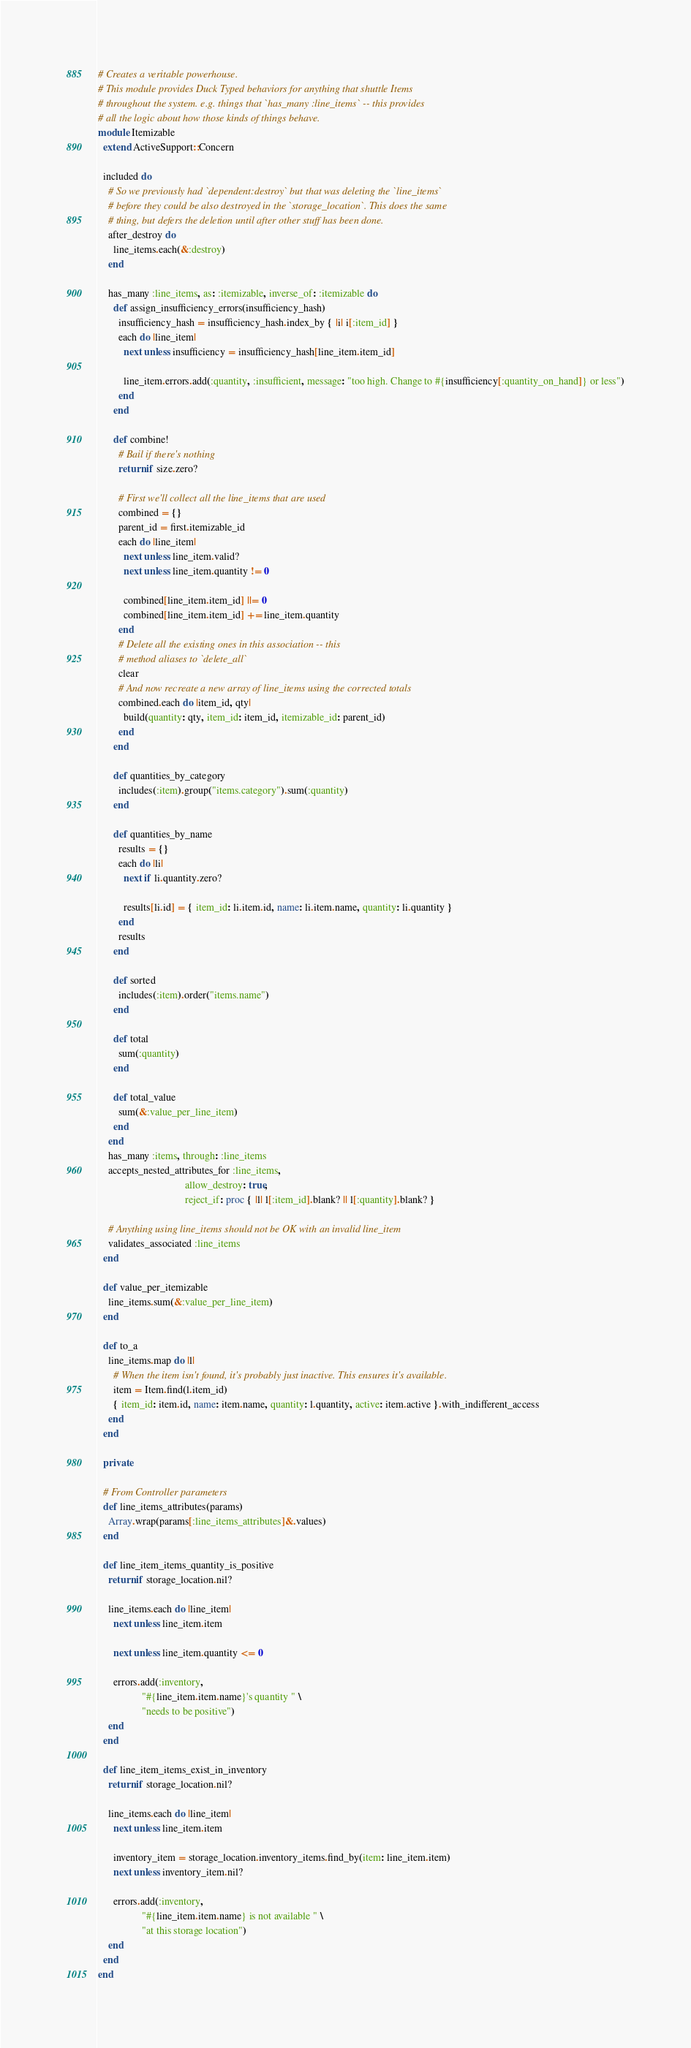Convert code to text. <code><loc_0><loc_0><loc_500><loc_500><_Ruby_># Creates a veritable powerhouse.
# This module provides Duck Typed behaviors for anything that shuttle Items
# throughout the system. e.g. things that `has_many :line_items` -- this provides
# all the logic about how those kinds of things behave.
module Itemizable
  extend ActiveSupport::Concern

  included do
    # So we previously had `dependent:destroy` but that was deleting the `line_items`
    # before they could be also destroyed in the `storage_location`. This does the same
    # thing, but defers the deletion until after other stuff has been done.
    after_destroy do
      line_items.each(&:destroy)
    end

    has_many :line_items, as: :itemizable, inverse_of: :itemizable do
      def assign_insufficiency_errors(insufficiency_hash)
        insufficiency_hash = insufficiency_hash.index_by { |i| i[:item_id] }
        each do |line_item|
          next unless insufficiency = insufficiency_hash[line_item.item_id]

          line_item.errors.add(:quantity, :insufficient, message: "too high. Change to #{insufficiency[:quantity_on_hand]} or less")
        end
      end

      def combine!
        # Bail if there's nothing
        return if size.zero?

        # First we'll collect all the line_items that are used
        combined = {}
        parent_id = first.itemizable_id
        each do |line_item|
          next unless line_item.valid?
          next unless line_item.quantity != 0

          combined[line_item.item_id] ||= 0
          combined[line_item.item_id] += line_item.quantity
        end
        # Delete all the existing ones in this association -- this
        # method aliases to `delete_all`
        clear
        # And now recreate a new array of line_items using the corrected totals
        combined.each do |item_id, qty|
          build(quantity: qty, item_id: item_id, itemizable_id: parent_id)
        end
      end

      def quantities_by_category
        includes(:item).group("items.category").sum(:quantity)
      end

      def quantities_by_name
        results = {}
        each do |li|
          next if li.quantity.zero?

          results[li.id] = { item_id: li.item.id, name: li.item.name, quantity: li.quantity }
        end
        results
      end

      def sorted
        includes(:item).order("items.name")
      end

      def total
        sum(:quantity)
      end

      def total_value
        sum(&:value_per_line_item)
      end
    end
    has_many :items, through: :line_items
    accepts_nested_attributes_for :line_items,
                                  allow_destroy: true,
                                  reject_if: proc { |l| l[:item_id].blank? || l[:quantity].blank? }

    # Anything using line_items should not be OK with an invalid line_item
    validates_associated :line_items
  end

  def value_per_itemizable
    line_items.sum(&:value_per_line_item)
  end

  def to_a
    line_items.map do |l|
      # When the item isn't found, it's probably just inactive. This ensures it's available.
      item = Item.find(l.item_id)
      { item_id: item.id, name: item.name, quantity: l.quantity, active: item.active }.with_indifferent_access
    end
  end

  private

  # From Controller parameters
  def line_items_attributes(params)
    Array.wrap(params[:line_items_attributes]&.values)
  end

  def line_item_items_quantity_is_positive
    return if storage_location.nil?

    line_items.each do |line_item|
      next unless line_item.item

      next unless line_item.quantity <= 0

      errors.add(:inventory,
                 "#{line_item.item.name}'s quantity " \
                 "needs to be positive")
    end
  end

  def line_item_items_exist_in_inventory
    return if storage_location.nil?

    line_items.each do |line_item|
      next unless line_item.item

      inventory_item = storage_location.inventory_items.find_by(item: line_item.item)
      next unless inventory_item.nil?

      errors.add(:inventory,
                 "#{line_item.item.name} is not available " \
                 "at this storage location")
    end
  end
end
</code> 